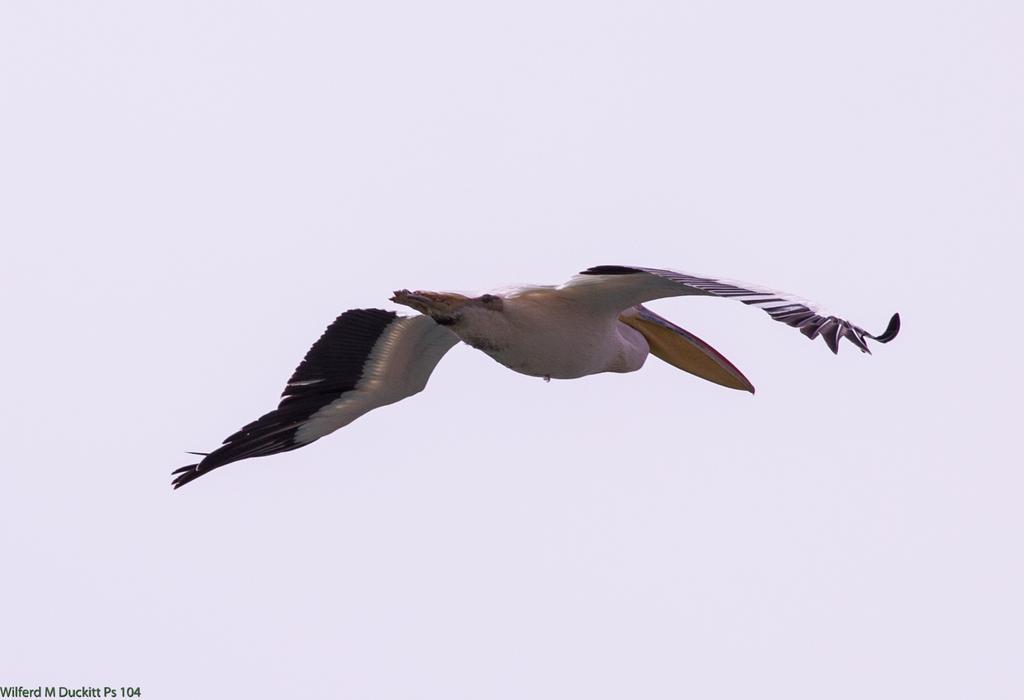In one or two sentences, can you explain what this image depicts? In this image there is a bird flying in the sky, in the bottom left there is some text. 